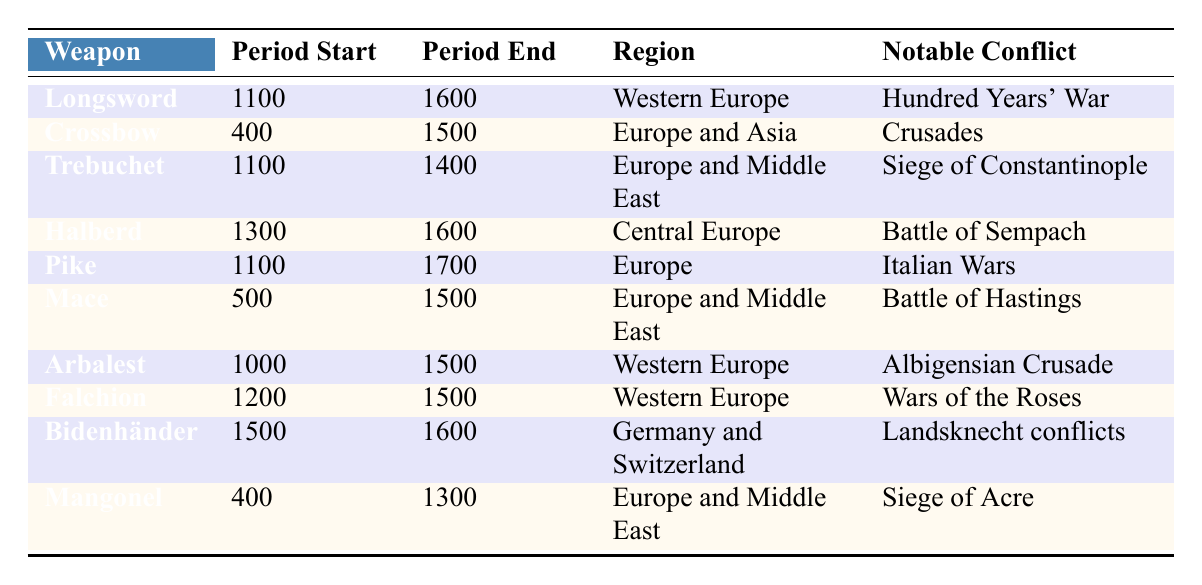What is the period of use for the Longsword? The table shows that the Longsword had a period of use starting in 1100 and ending in 1600.
Answer: 1100 to 1600 Which weapon was used during the Crusades? The table indicates that the Crossbow was notable during the Crusades, with its period of use from 400 to 1500.
Answer: Crossbow What is the notable conflict associated with the Halberd? According to the table, the Halberd is linked to the Battle of Sempach.
Answer: Battle of Sempach Which weapon has the longest period of use? The Pike has a period starting in 1100 and ending in 1700, which spans 600 years, making it the longest.
Answer: Pike Is the Trebuchet associated with any conflict after 1400? The table lists the Trebuchet's period of use from 1100 to 1400, so it is not associated with any conflict after 1400.
Answer: No How many weapons were used in notable conflicts before the year 1200? The Crossbow, Mangonel, and Trebuchet are the three weapons with periods starting before 1200, related to the Crusades, Siege of Acre, and Siege of Constantinople.
Answer: Three What is the average ending year of all the listed weapons? The end years for the weapons are 1600, 1500, 1400, 1600, 1700, 1500, 1500, 1500, 1600, and 1300. Summing these yields 15,600, and with 10 weapons, the average is 1560.
Answer: 1560 Which region saw the use of the Mace during significant conflicts? The table identifies that the Mace was used in both Europe and the Middle East, particularly noted in the Battle of Hastings.
Answer: Europe and Middle East How many weapons were used in conflicts specifically in Western Europe? The Longsword, Arbalest, and Falchion were noted to be used in conflicts in Western Europe, bringing the count to three weapons.
Answer: Three Which weapon had a period exclusively in the 1500s? The Bidenhänder is the only weapon with a defined period from 1500 to 1600, establishing its exclusive use in that century.
Answer: Bidenhänder 